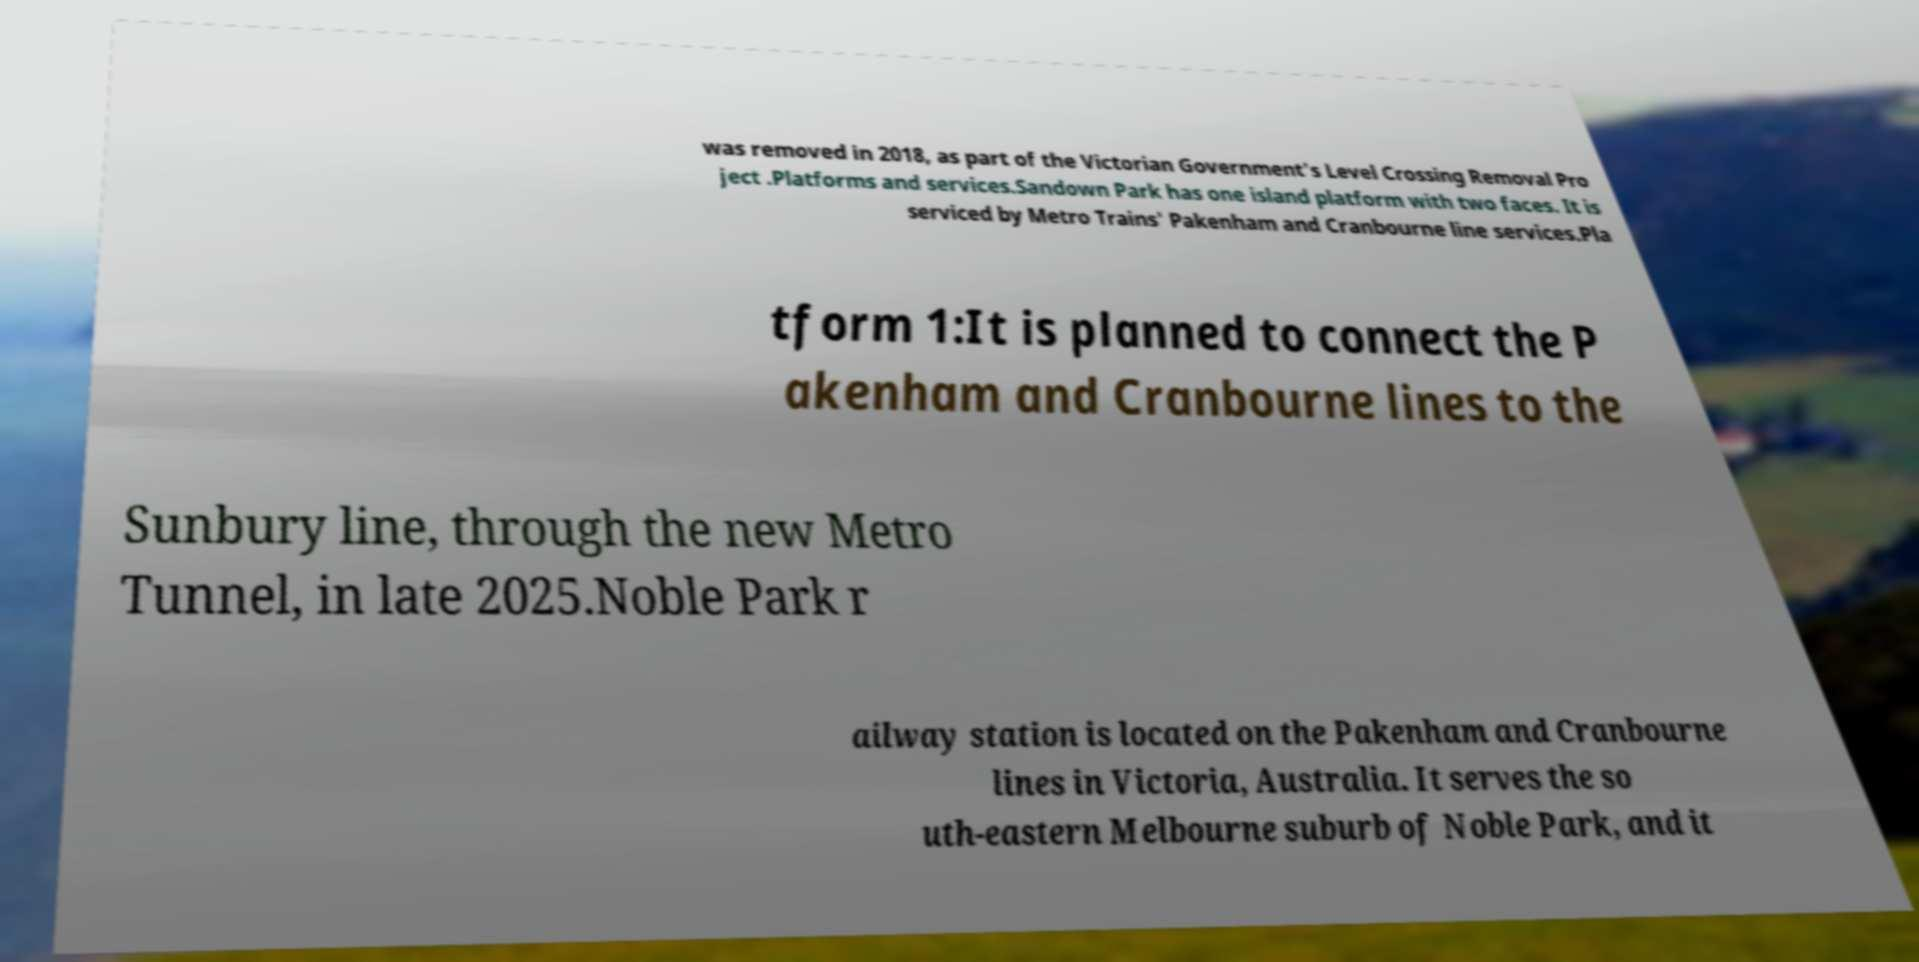Could you assist in decoding the text presented in this image and type it out clearly? was removed in 2018, as part of the Victorian Government's Level Crossing Removal Pro ject .Platforms and services.Sandown Park has one island platform with two faces. It is serviced by Metro Trains' Pakenham and Cranbourne line services.Pla tform 1:It is planned to connect the P akenham and Cranbourne lines to the Sunbury line, through the new Metro Tunnel, in late 2025.Noble Park r ailway station is located on the Pakenham and Cranbourne lines in Victoria, Australia. It serves the so uth-eastern Melbourne suburb of Noble Park, and it 